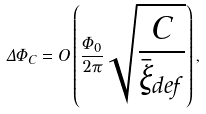<formula> <loc_0><loc_0><loc_500><loc_500>\Delta \Phi _ { C } = O \left ( \frac { \Phi _ { 0 } } { 2 \pi } \sqrt { \frac { C } { { \bar { \xi } } _ { d e f } } } \right ) ,</formula> 